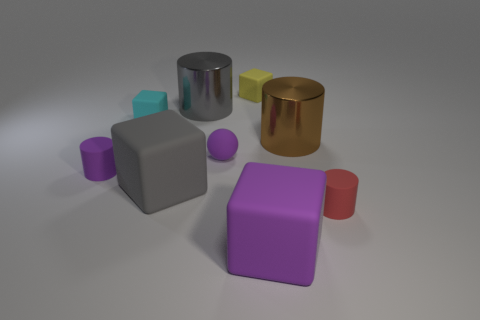What is the shape of the tiny rubber object that is the same color as the ball?
Ensure brevity in your answer.  Cylinder. Is the big brown object made of the same material as the purple cube?
Provide a short and direct response. No. What is the size of the purple cylinder that is made of the same material as the purple cube?
Your answer should be very brief. Small. The thing that is right of the purple rubber cube and in front of the purple rubber cylinder has what shape?
Give a very brief answer. Cylinder. Are there more small red things than small yellow shiny objects?
Ensure brevity in your answer.  Yes. Are there more tiny cyan blocks to the right of the small red object than big cylinders to the right of the small yellow matte cube?
Give a very brief answer. No. What is the size of the object that is right of the big purple matte object and behind the small ball?
Provide a succinct answer. Large. How many purple blocks have the same size as the cyan matte thing?
Ensure brevity in your answer.  0. There is a small thing that is the same color as the small sphere; what material is it?
Provide a short and direct response. Rubber. There is a matte object that is in front of the small red thing; is its shape the same as the small red thing?
Provide a succinct answer. No. 